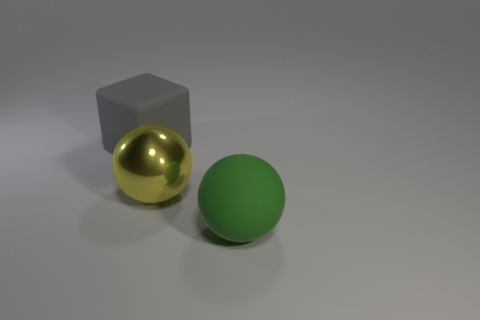Add 1 large green objects. How many objects exist? 4 Subtract 1 blocks. How many blocks are left? 0 Subtract all green balls. How many balls are left? 1 Subtract all blocks. How many objects are left? 2 Subtract all green balls. Subtract all yellow blocks. How many balls are left? 1 Subtract all blue cylinders. How many yellow balls are left? 1 Subtract all big yellow metal balls. Subtract all yellow spheres. How many objects are left? 1 Add 3 gray objects. How many gray objects are left? 4 Add 2 green things. How many green things exist? 3 Subtract 0 brown cylinders. How many objects are left? 3 